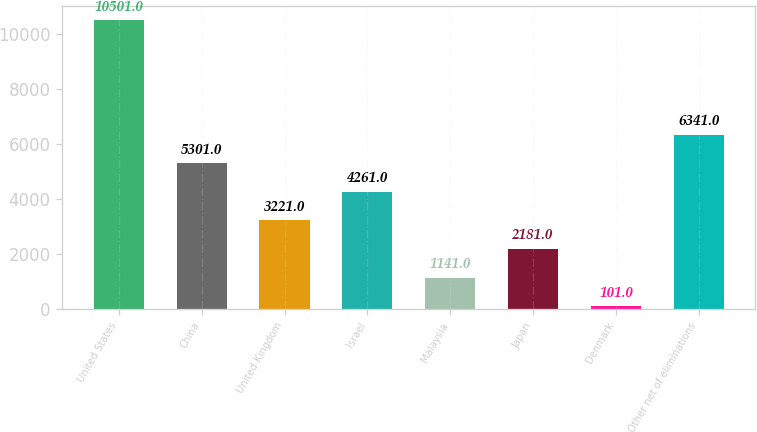Convert chart to OTSL. <chart><loc_0><loc_0><loc_500><loc_500><bar_chart><fcel>United States<fcel>China<fcel>United Kingdom<fcel>Israel<fcel>Malaysia<fcel>Japan<fcel>Denmark<fcel>Other net of eliminations<nl><fcel>10501<fcel>5301<fcel>3221<fcel>4261<fcel>1141<fcel>2181<fcel>101<fcel>6341<nl></chart> 